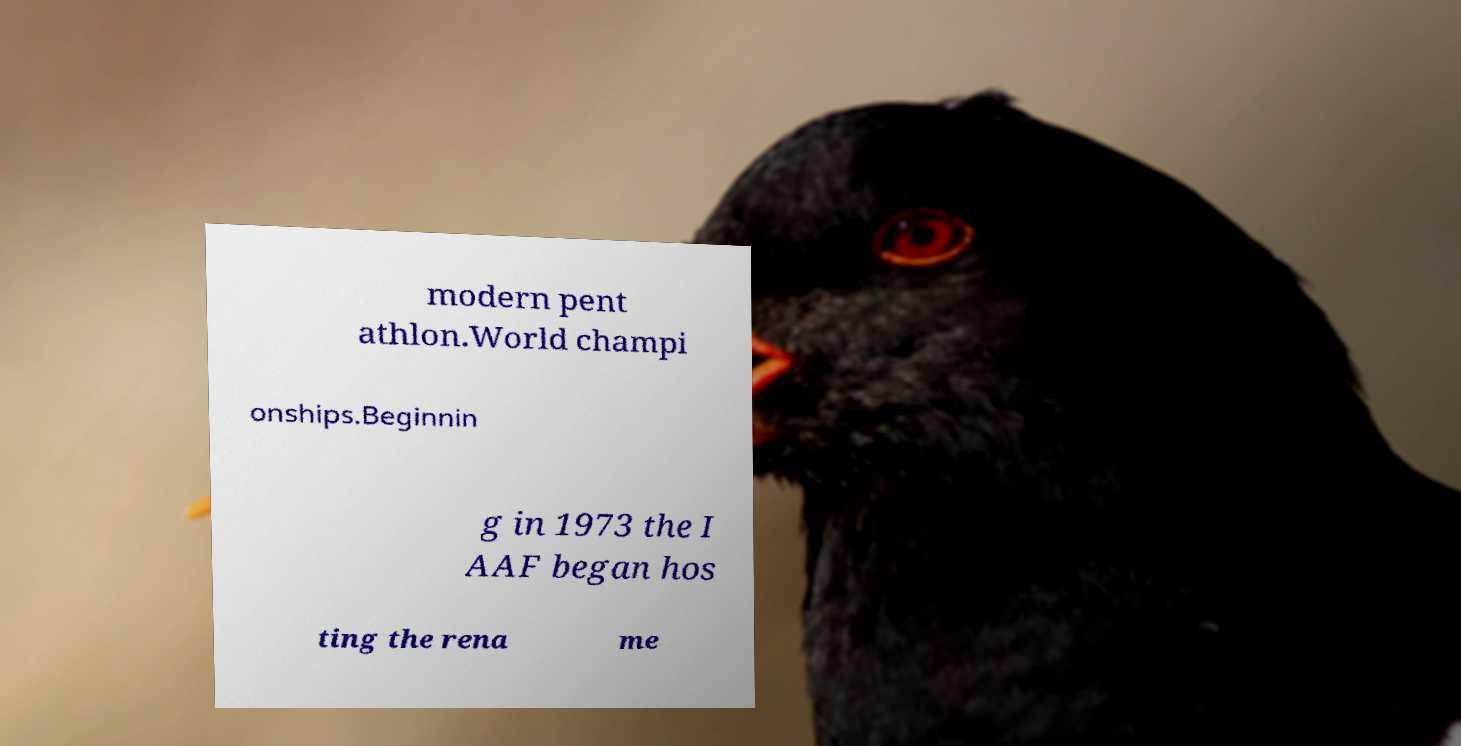Could you extract and type out the text from this image? modern pent athlon.World champi onships.Beginnin g in 1973 the I AAF began hos ting the rena me 